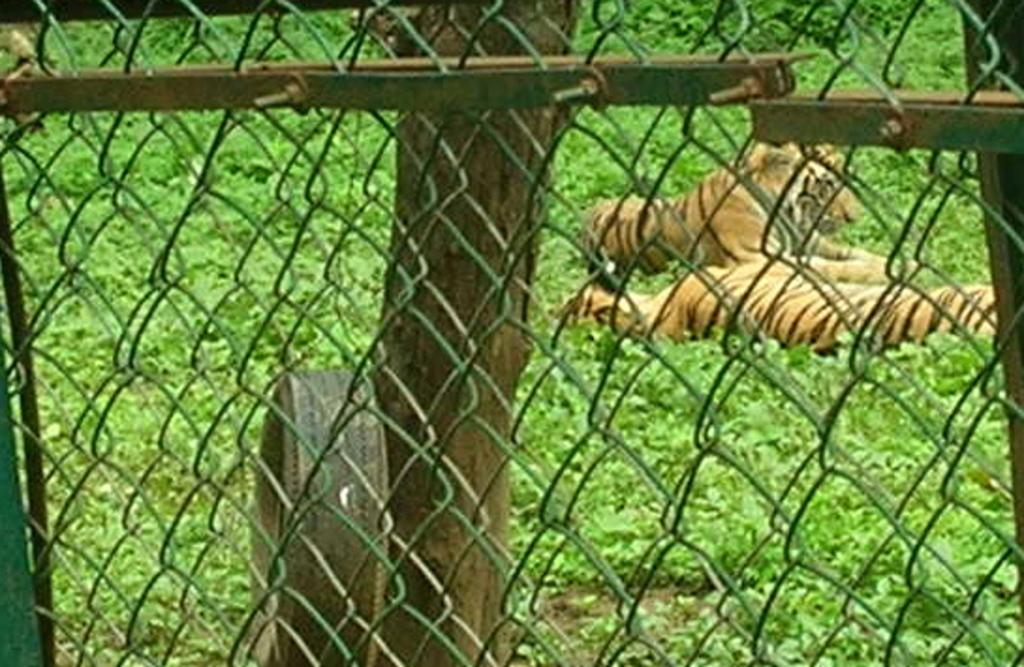What type of barrier can be seen in the image? There is a metal fence in the image. What objects are visible in the background of the image? There is a tyre and a trunk in the background of the image. What type of vegetation is present in the image? There is grass visible in the image. What is happening on the grass in the image? There are animals on the grass in the image. What colors are the animals? The animals are brown and black in color. What type of trousers are the animals wearing in the image? The animals in the image are not wearing trousers; they are animals and do not wear clothing. 